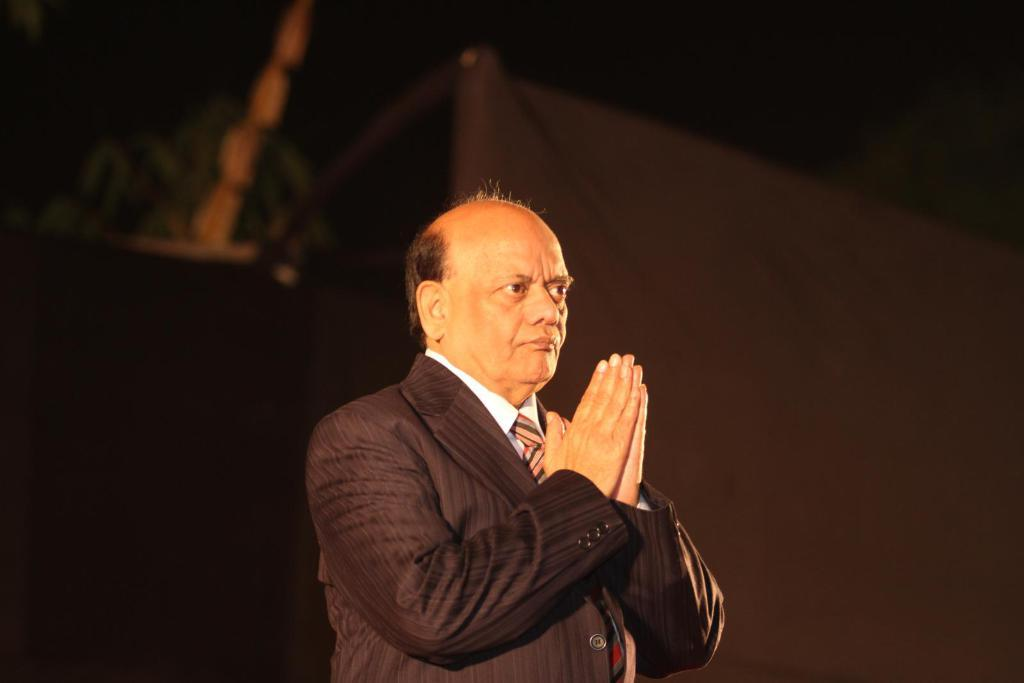What is the main subject of the image? The main subject of the image is a man. What is the man wearing in the image? The man is wearing a coat, a tie, and a shirt in the image. What is the man doing in the image? The man is joining his both hands in the image. What is the tax rate for the man in the image? There is no information about tax rates in the image, as it only shows a man wearing a coat, tie, and shirt, and joining his both hands. 